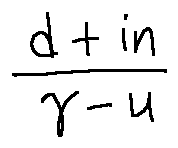Convert formula to latex. <formula><loc_0><loc_0><loc_500><loc_500>\frac { d + i n } { \gamma - u }</formula> 